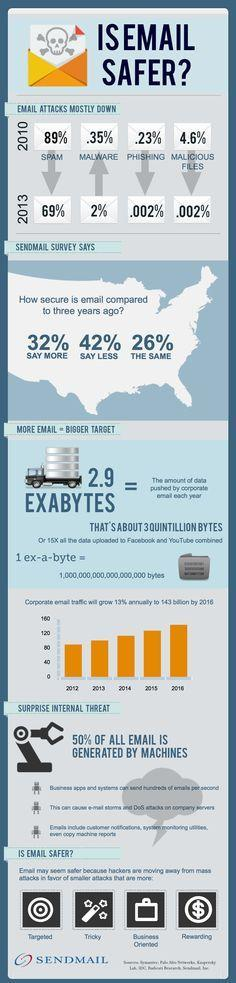Has the malware attacks from 2010 to 2013  increased or decreased?
Answer the question with a short phrase. increased how many feel that email security is the same compared to three years ago? 26% How much percentage of  spam mail decreased by 2013 from 2010? 20 